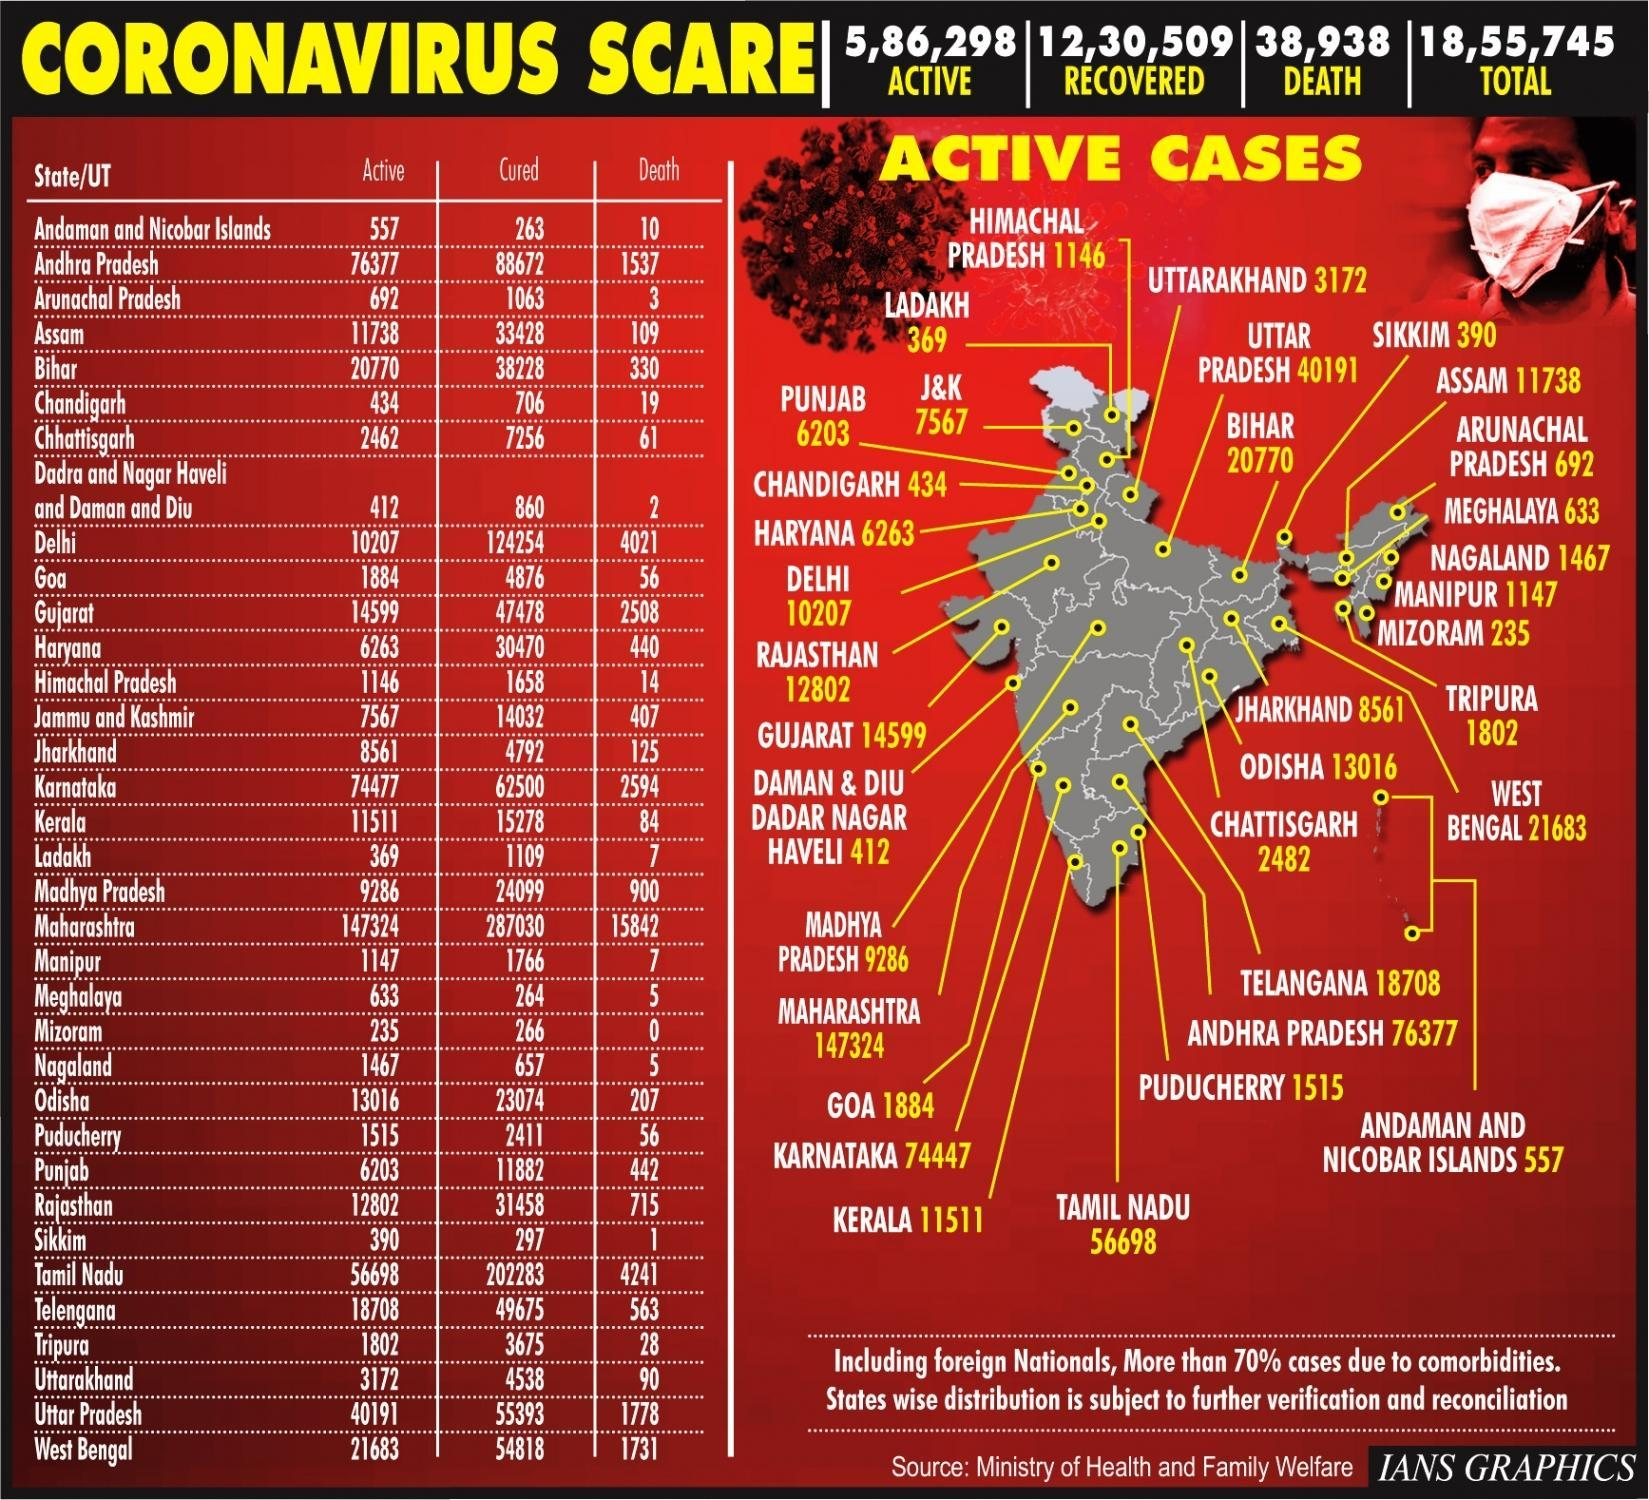Which is the state in India with Zero corona deaths?
Answer the question with a short phrase. Mizoram How many states in India had 5 corona deaths? 2 How many state/UT listed has corona deaths more than 4000? 3 What is the number of corona active cases in northern most union territory of India? 369 How many persons died in India due to corona? 38,938 How many people in India have recovered from corona? 12,30,509 Which state in India has the highest no of deaths due to Corona? Maharashtra Which state has the highest no of corona active cases? Maharashtra 